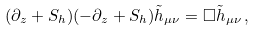Convert formula to latex. <formula><loc_0><loc_0><loc_500><loc_500>( \partial _ { z } + S _ { h } ) ( - \partial _ { z } + S _ { h } ) \tilde { h } _ { \mu \nu } = \Box \tilde { h } _ { \mu \nu } \, ,</formula> 